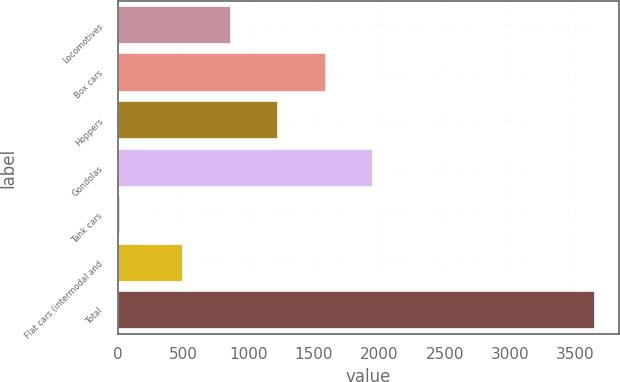Convert chart. <chart><loc_0><loc_0><loc_500><loc_500><bar_chart><fcel>Locomotives<fcel>Box cars<fcel>Hoppers<fcel>Gondolas<fcel>Tank cars<fcel>Flat cars (intermodal and<fcel>Total<nl><fcel>864.3<fcel>1590.9<fcel>1227.6<fcel>1954.2<fcel>15<fcel>501<fcel>3648<nl></chart> 